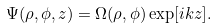<formula> <loc_0><loc_0><loc_500><loc_500>\Psi ( \rho , \phi , z ) = \Omega ( \rho , \phi ) \exp [ i k z ] .</formula> 